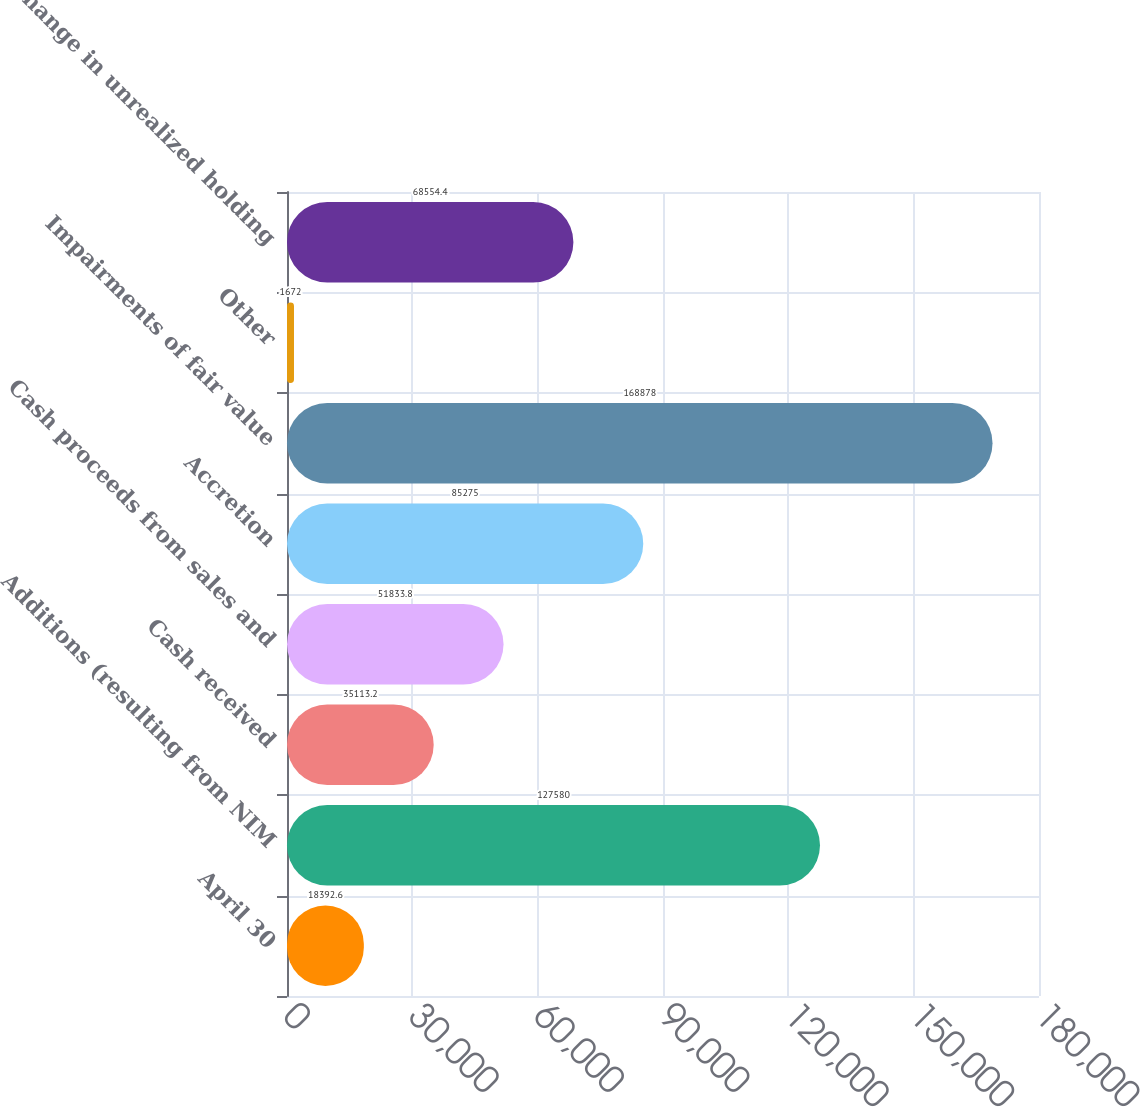Convert chart. <chart><loc_0><loc_0><loc_500><loc_500><bar_chart><fcel>April 30<fcel>Additions (resulting from NIM<fcel>Cash received<fcel>Cash proceeds from sales and<fcel>Accretion<fcel>Impairments of fair value<fcel>Other<fcel>Change in unrealized holding<nl><fcel>18392.6<fcel>127580<fcel>35113.2<fcel>51833.8<fcel>85275<fcel>168878<fcel>1672<fcel>68554.4<nl></chart> 